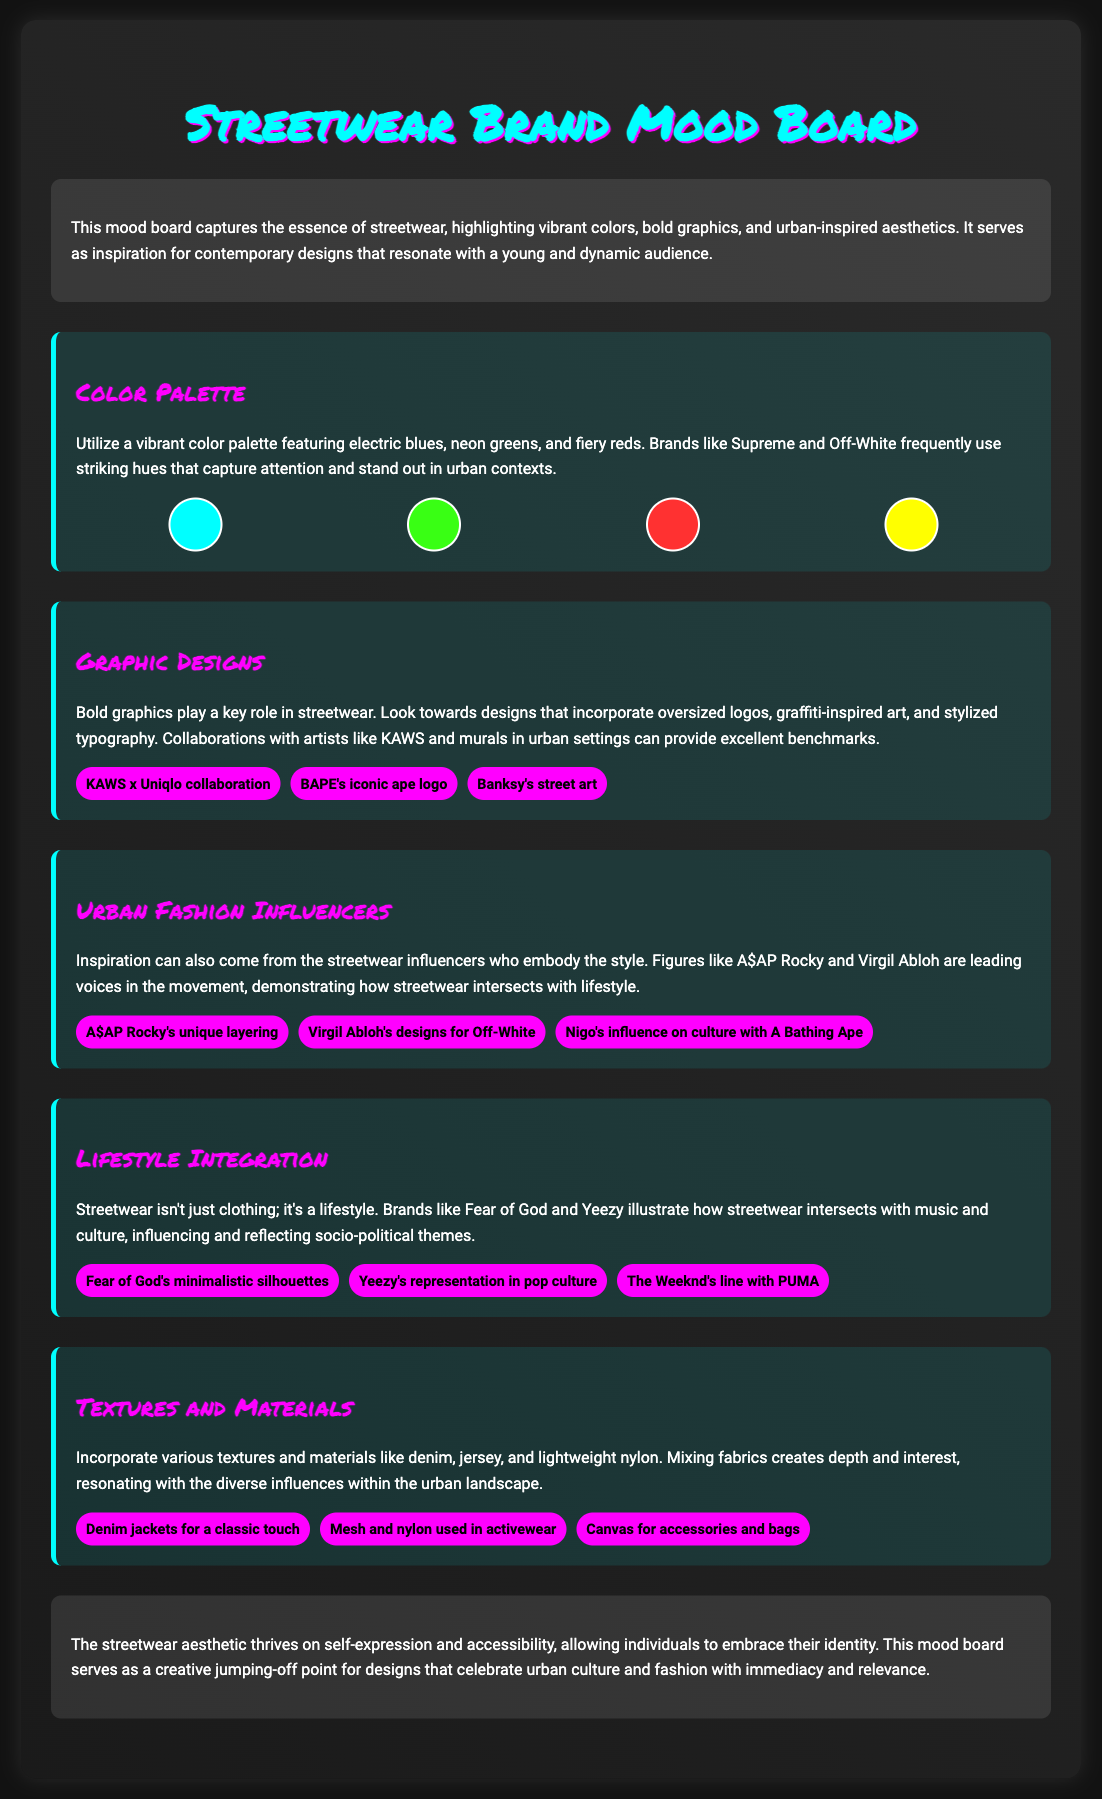What are the dominant colors in the palette? The document mentions the vibrant color palette featuring electric blues, neon greens, and fiery reds.
Answer: electric blues, neon greens, fiery reds Who are the urban fashion influencers mentioned? The mood board lists A$AP Rocky and Virgil Abloh as significant figures in streetwear.
Answer: A$AP Rocky, Virgil Abloh What type of textures and materials are suggested? The document discusses incorporating various textures and materials like denim, jersey, and lightweight nylon.
Answer: denim, jersey, lightweight nylon Which brand is associated with minimalistic silhouettes? The document states that Fear of God is known for its minimalistic silhouettes.
Answer: Fear of God What is the purpose of the mood board? The mood board's introduction indicates that it serves as inspiration for designs that resonate with a young and dynamic audience.
Answer: inspiration for contemporary designs How does streetwear intersect with music and culture? The text explains that brands like Fear of God and Yeezy illustrate this intersection in the lifestyle of streetwear.
Answer: streetwear lifestyle What kind of graphic designs are emphasized? The document highlights bold graphics that incorporate oversized logos, graffiti-inspired art, and stylized typography.
Answer: oversized logos, graffiti-inspired art, stylized typography Which collaboration is provided as an example of graphic design? The document mentions the KAWS x Uniqlo collaboration as an example of bold graphic designs.
Answer: KAWS x Uniqlo collaboration 